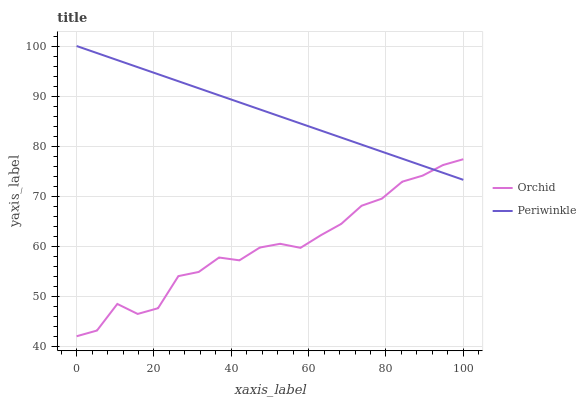Does Orchid have the minimum area under the curve?
Answer yes or no. Yes. Does Periwinkle have the maximum area under the curve?
Answer yes or no. Yes. Does Orchid have the maximum area under the curve?
Answer yes or no. No. Is Periwinkle the smoothest?
Answer yes or no. Yes. Is Orchid the roughest?
Answer yes or no. Yes. Is Orchid the smoothest?
Answer yes or no. No. Does Orchid have the highest value?
Answer yes or no. No. 